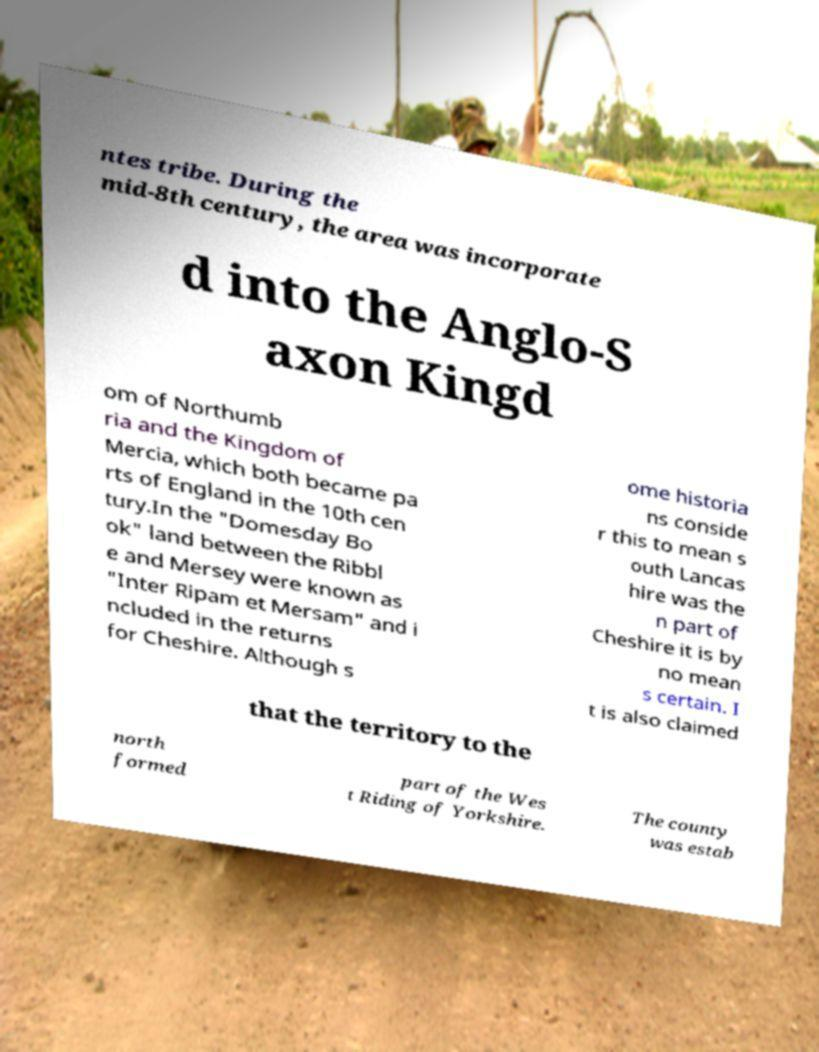What messages or text are displayed in this image? I need them in a readable, typed format. ntes tribe. During the mid-8th century, the area was incorporate d into the Anglo-S axon Kingd om of Northumb ria and the Kingdom of Mercia, which both became pa rts of England in the 10th cen tury.In the "Domesday Bo ok" land between the Ribbl e and Mersey were known as "Inter Ripam et Mersam" and i ncluded in the returns for Cheshire. Although s ome historia ns conside r this to mean s outh Lancas hire was the n part of Cheshire it is by no mean s certain. I t is also claimed that the territory to the north formed part of the Wes t Riding of Yorkshire. The county was estab 